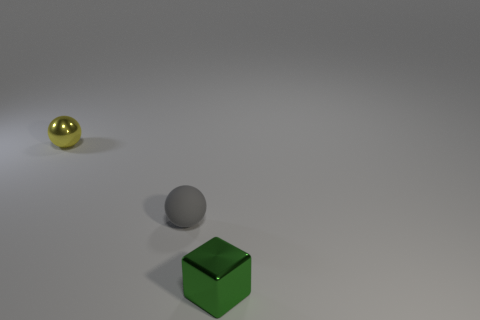Is there anything else that is made of the same material as the gray thing?
Your response must be concise. No. Is the material of the small gray object the same as the small thing behind the gray rubber object?
Your response must be concise. No. Are there an equal number of gray rubber balls that are right of the small gray matte thing and green blocks that are right of the metal ball?
Give a very brief answer. No. Do the gray matte ball and the shiny thing behind the small metallic block have the same size?
Provide a short and direct response. Yes. Are there more small spheres in front of the small metal sphere than small brown shiny cylinders?
Your answer should be very brief. Yes. How many cubes have the same size as the shiny ball?
Keep it short and to the point. 1. Does the thing that is on the right side of the small matte ball have the same size as the thing behind the gray matte thing?
Offer a terse response. Yes. Are there more metal spheres behind the small green cube than green metal objects that are behind the small gray sphere?
Provide a succinct answer. Yes. How many tiny gray matte things are the same shape as the small green metallic object?
Provide a succinct answer. 0. What material is the yellow object that is the same size as the green shiny object?
Provide a succinct answer. Metal. 